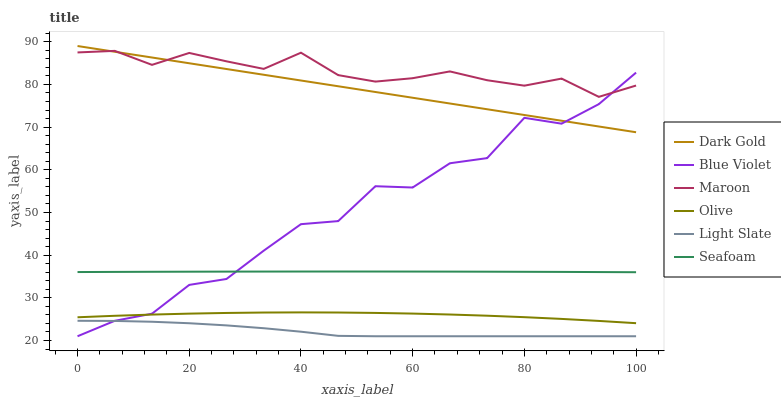Does Light Slate have the minimum area under the curve?
Answer yes or no. Yes. Does Maroon have the maximum area under the curve?
Answer yes or no. Yes. Does Seafoam have the minimum area under the curve?
Answer yes or no. No. Does Seafoam have the maximum area under the curve?
Answer yes or no. No. Is Dark Gold the smoothest?
Answer yes or no. Yes. Is Blue Violet the roughest?
Answer yes or no. Yes. Is Light Slate the smoothest?
Answer yes or no. No. Is Light Slate the roughest?
Answer yes or no. No. Does Light Slate have the lowest value?
Answer yes or no. Yes. Does Seafoam have the lowest value?
Answer yes or no. No. Does Dark Gold have the highest value?
Answer yes or no. Yes. Does Seafoam have the highest value?
Answer yes or no. No. Is Light Slate less than Olive?
Answer yes or no. Yes. Is Maroon greater than Seafoam?
Answer yes or no. Yes. Does Dark Gold intersect Maroon?
Answer yes or no. Yes. Is Dark Gold less than Maroon?
Answer yes or no. No. Is Dark Gold greater than Maroon?
Answer yes or no. No. Does Light Slate intersect Olive?
Answer yes or no. No. 